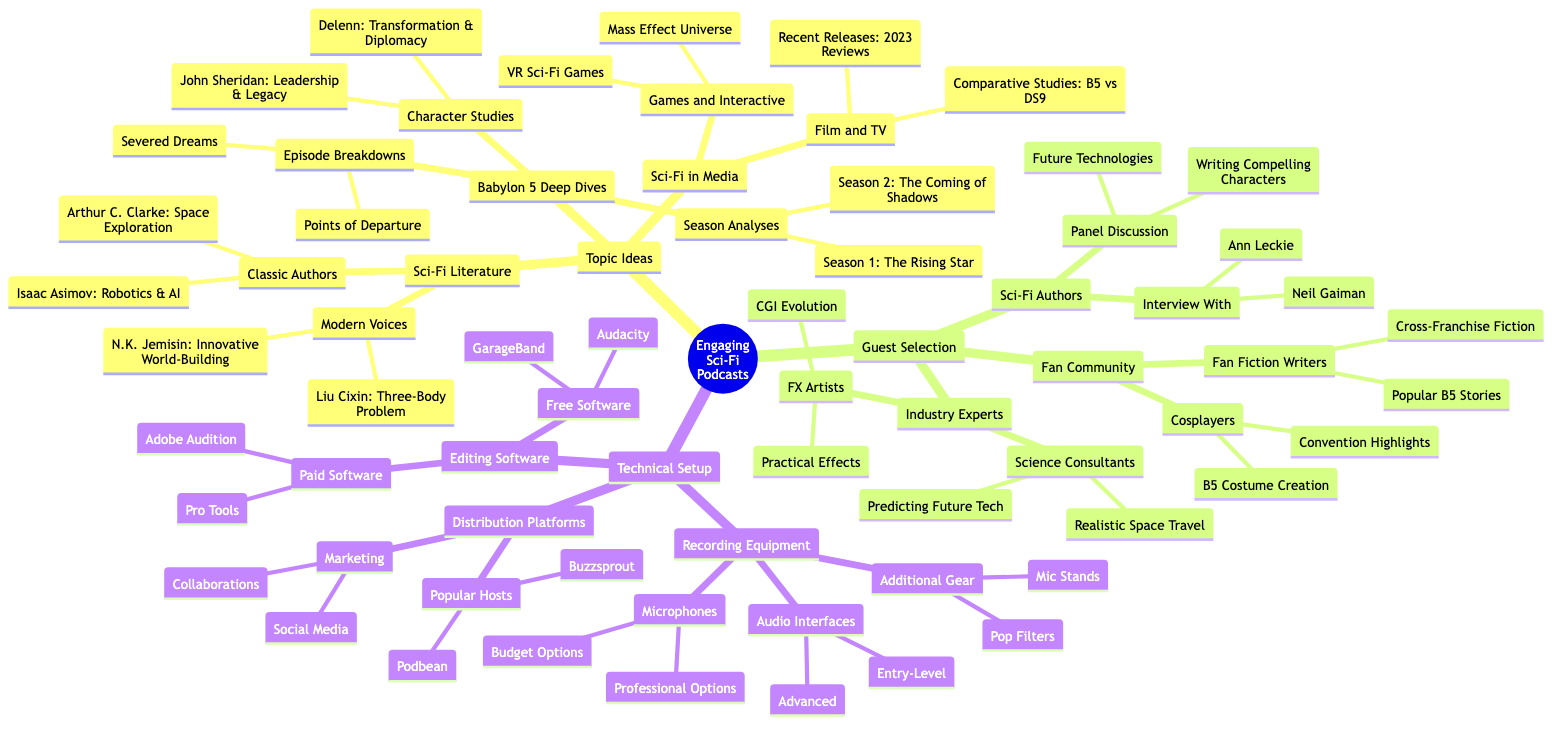What are the three main categories under Topic Ideas? The main categories under Topic Ideas are Babylon 5 Deep Dives, Sci-Fi Literature, and Sci-Fi in Media. These categories are the first level of the mind map branching from the central theme of Engaging Sci-Fi Podcasts.
Answer: Babylon 5 Deep Dives, Sci-Fi Literature, Sci-Fi in Media How many guest selection categories are there? There are three guest selection categories listed in the mind map: Sci-Fi Authors, Industry Experts, and Fan Community. Each of these categories expands into more specific subcategories.
Answer: 3 What is the focus of the Character Studies subcategory? The Character Studies subcategory specifically focuses on characters John Sheridan and Delenn, exploring themes like leadership, legacy, transformation, and diplomacy. These are individual nodes connected to the broader Character Studies section.
Answer: John Sheridan, Delenn Which editing software is listed as a paid option? The mind map details Adobe Audition and Pro Tools as paid software options for editing, indicating that they are among the choices for podcasters looking for advanced editing capabilities.
Answer: Adobe Audition, Pro Tools How many notable titles are under the Games and Interactive category? There are two notable titles listed under the Games and Interactive category: Mass Effect Universe and VR Sci-Fi Games, showing the focus on interactive experiences within the sci-fi genre.
Answer: 2 What type of guest discussion is represented by Panel1? Panel1 represents a discussion on Future Technologies in Sci-Fi, indicating the type of topics that could be explored with guests during panel discussions.
Answer: Future Technologies Which recording equipment category contains pop filters? The Additional Gear subcategory under Recording Equipment includes pop filters, highlighting the necessity of various accessories for optimal podcasting sound quality.
Answer: Additional Gear What popular distribution host is named in the diagram? Podbean is mentioned as a popular distribution host, indicating it as one of the platforms where podcasts can be set up and distributed effectively.
Answer: Podbean What two classifications are listed under the Modern Voices in Sci-Fi Literature? The Modern Voices category includes N.K. Jemisin and Liu Cixin, identifying these authors as significant contemporary figures in the sci-fi literature space.
Answer: N.K. Jemisin, Liu Cixin 